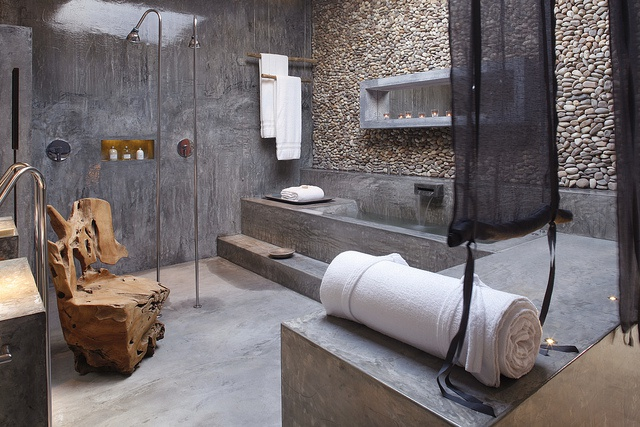Describe the objects in this image and their specific colors. I can see chair in black, maroon, gray, and tan tones, bowl in black, darkgray, and gray tones, bottle in black, maroon, darkgray, and gray tones, and bottle in black, darkgray, and gray tones in this image. 